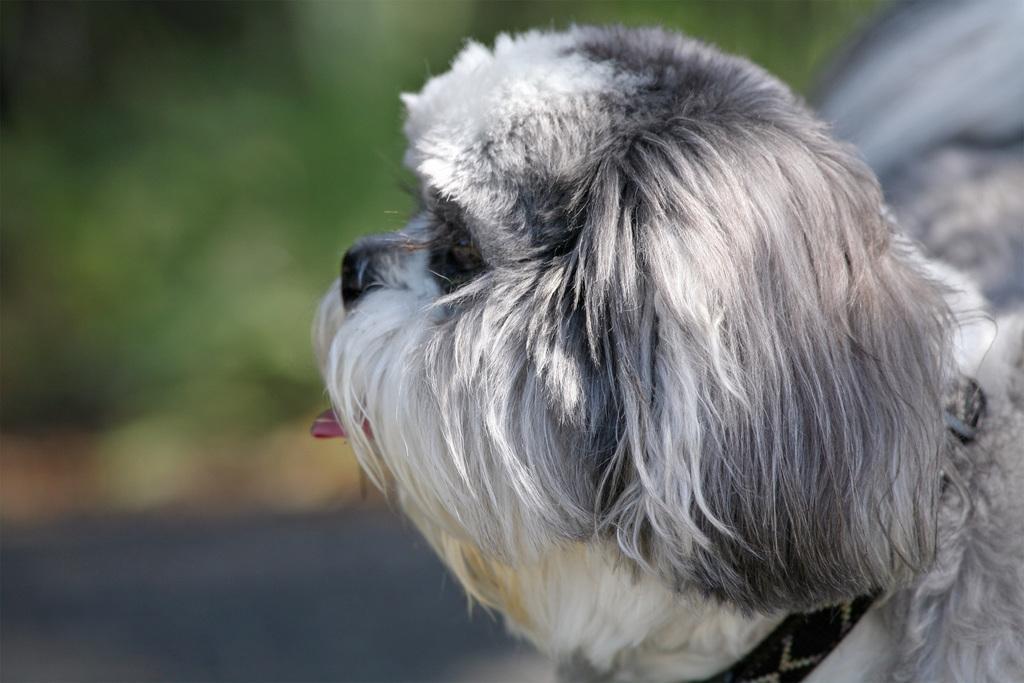Please provide a concise description of this image. In this image I can see the dog which is in white and black color. I can see the black color belt to the dog. In the background I can see the trees but it is blurry. 